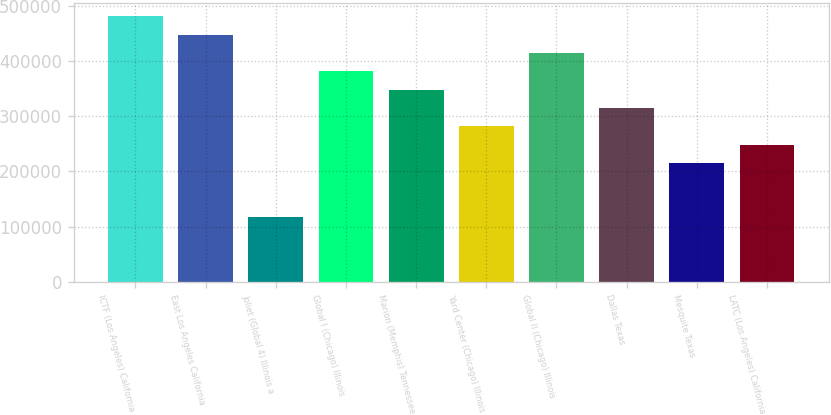Convert chart to OTSL. <chart><loc_0><loc_0><loc_500><loc_500><bar_chart><fcel>ICTF (Los Angeles) California<fcel>East Los Angeles California<fcel>Joliet (Global 4) Illinois a<fcel>Global I (Chicago) Illinois<fcel>Marion (Memphis) Tennessee<fcel>Yard Center (Chicago) Illinois<fcel>Global II (Chicago) Illinois<fcel>Dallas Texas<fcel>Mesquite Texas<fcel>LATC (Los Angeles) California<nl><fcel>480600<fcel>447400<fcel>118000<fcel>381000<fcel>347800<fcel>281400<fcel>414200<fcel>314600<fcel>215000<fcel>248200<nl></chart> 